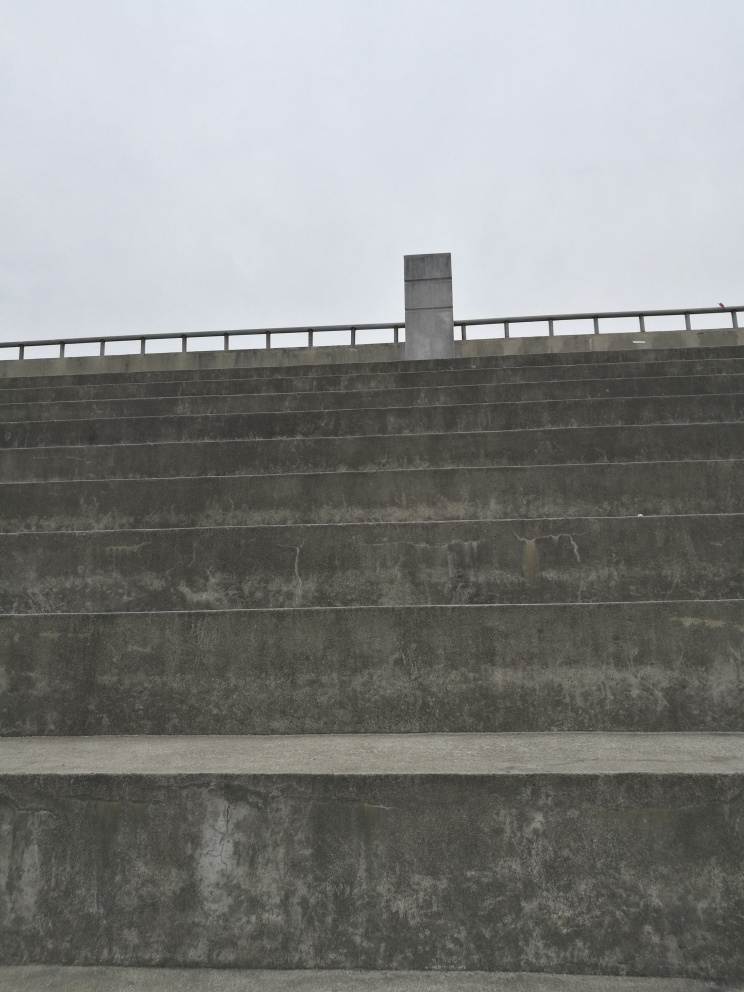How would you describe the clarity of the image? The clarity of the image is quite good as details are visible and no significant blurring is present. The texture of the concrete and the patterns of wear and staining on the staircase are clearly discernible, demonstrating the image's sharpness. 